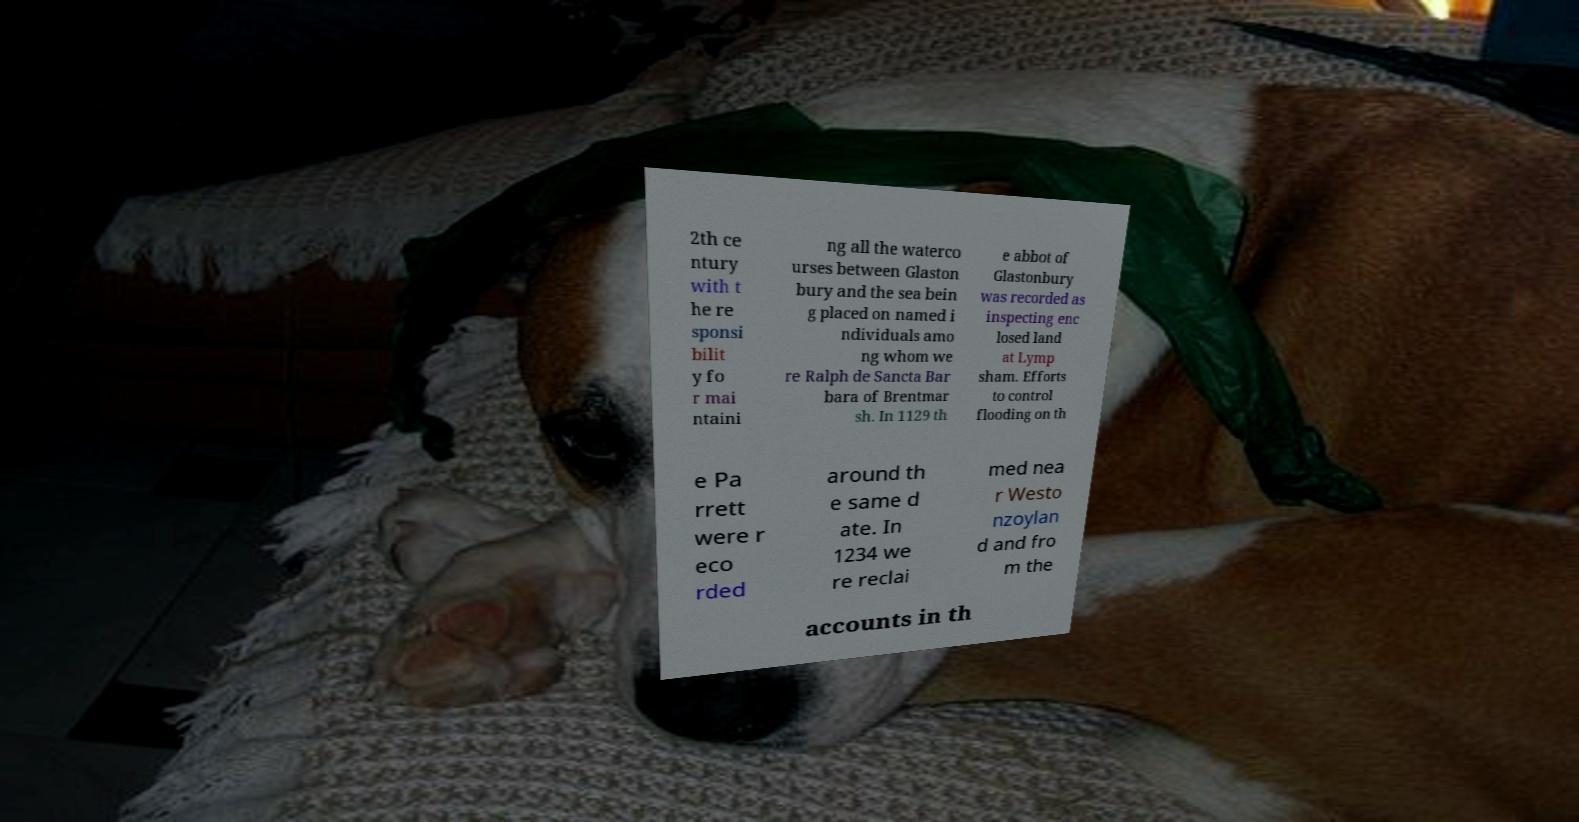Please read and relay the text visible in this image. What does it say? 2th ce ntury with t he re sponsi bilit y fo r mai ntaini ng all the waterco urses between Glaston bury and the sea bein g placed on named i ndividuals amo ng whom we re Ralph de Sancta Bar bara of Brentmar sh. In 1129 th e abbot of Glastonbury was recorded as inspecting enc losed land at Lymp sham. Efforts to control flooding on th e Pa rrett were r eco rded around th e same d ate. In 1234 we re reclai med nea r Westo nzoylan d and fro m the accounts in th 